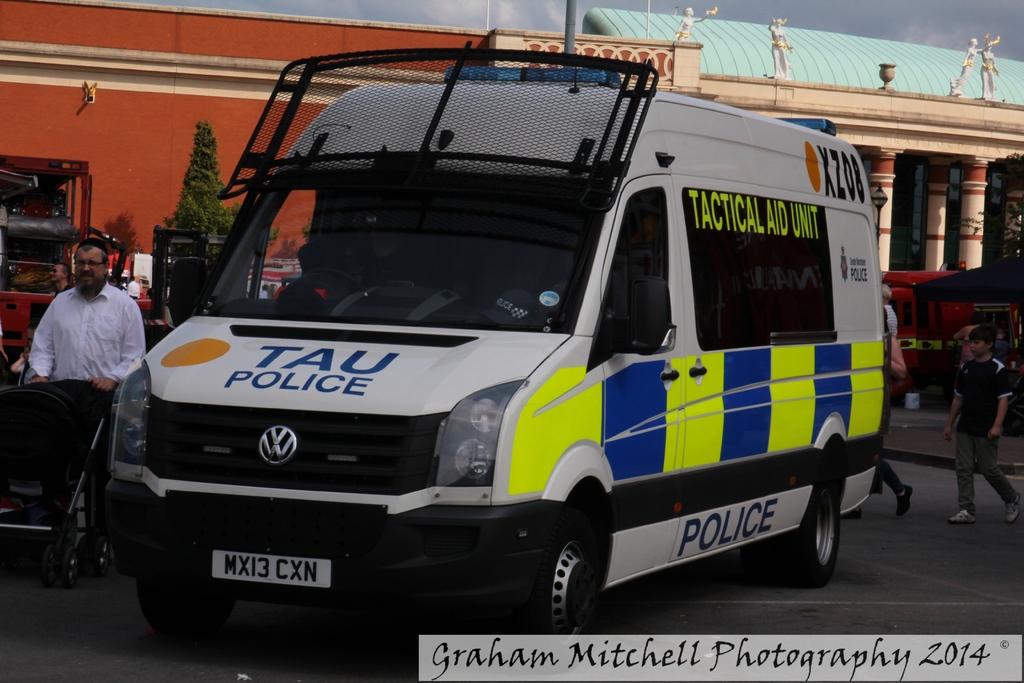This is police van?
Make the answer very short. Yes. 